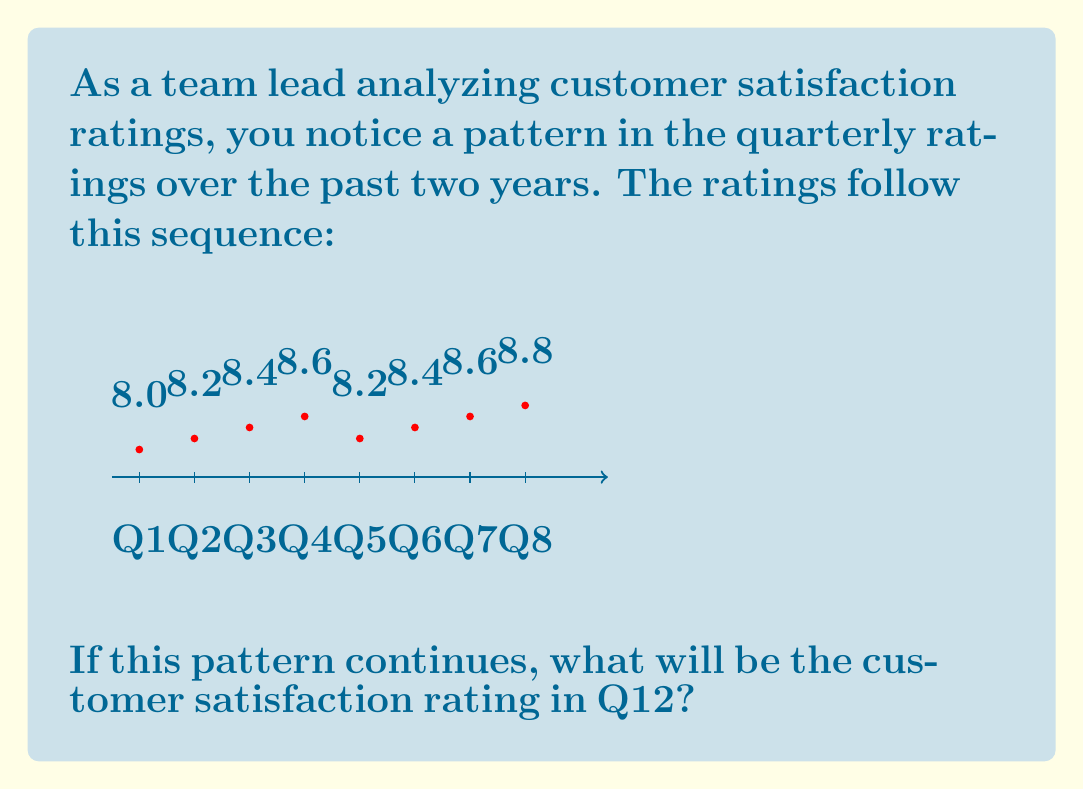Show me your answer to this math problem. To solve this problem, let's follow these steps:

1) Observe the pattern:
   Q1: 8.0
   Q2: 8.2
   Q3: 8.4
   Q4: 8.6
   Q5: 8.2
   Q6: 8.4
   Q7: 8.6
   Q8: 8.8

2) We can see that the pattern repeats every 4 quarters, but with an increase of 0.2 at the start of each cycle.

3) Let's express this mathematically:
   For any quarter $n$, the rating $R_n$ can be expressed as:
   $$R_n = 8.0 + 0.2 \times \left\lfloor\frac{n-1}{4}\right\rfloor + 0.2 \times ((n-1) \bmod 4)$$

   Where $\lfloor \cdot \rfloor$ is the floor function and $\bmod$ is the modulo operation.

4) For Q12, $n = 12$:
   $$R_{12} = 8.0 + 0.2 \times \left\lfloor\frac{11}{4}\right\rfloor + 0.2 \times (11 \bmod 4)$$

5) Simplify:
   $$R_{12} = 8.0 + 0.2 \times 2 + 0.2 \times 3$$
   $$R_{12} = 8.0 + 0.4 + 0.6 = 9.0$$

Therefore, if the pattern continues, the customer satisfaction rating in Q12 will be 9.0.
Answer: 9.0 